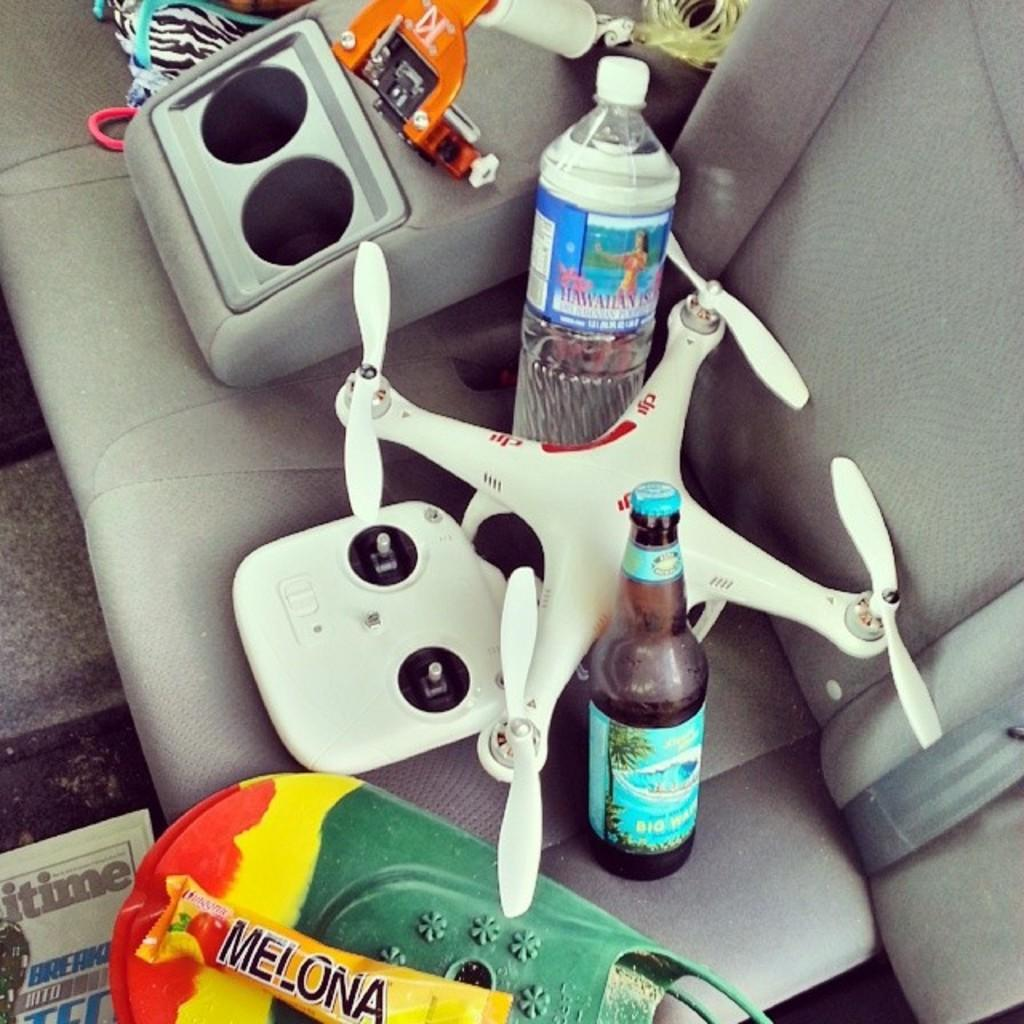<image>
Write a terse but informative summary of the picture. the backseat of a car with a bar wrapper that says 'melona' on it 